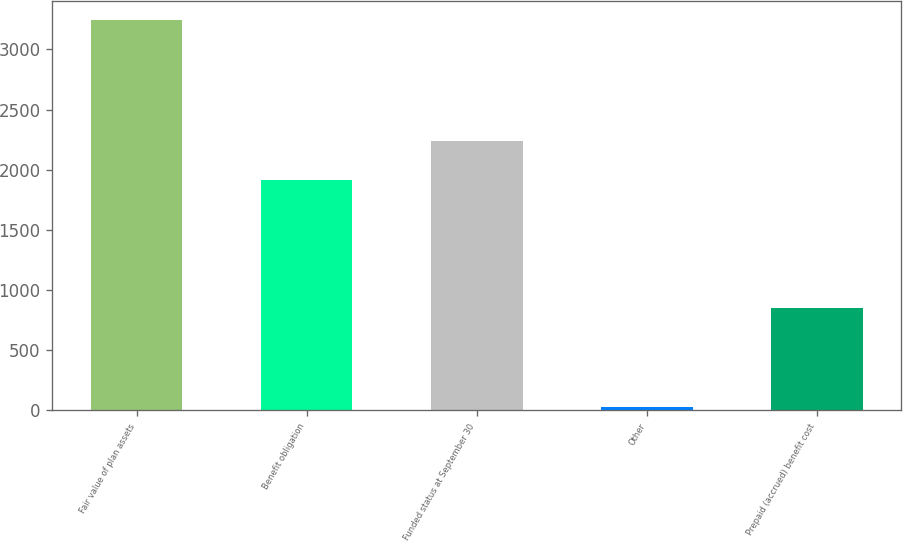<chart> <loc_0><loc_0><loc_500><loc_500><bar_chart><fcel>Fair value of plan assets<fcel>Benefit obligation<fcel>Funded status at September 30<fcel>Other<fcel>Prepaid (accrued) benefit cost<nl><fcel>3243<fcel>1917.7<fcel>2239.4<fcel>26<fcel>851<nl></chart> 